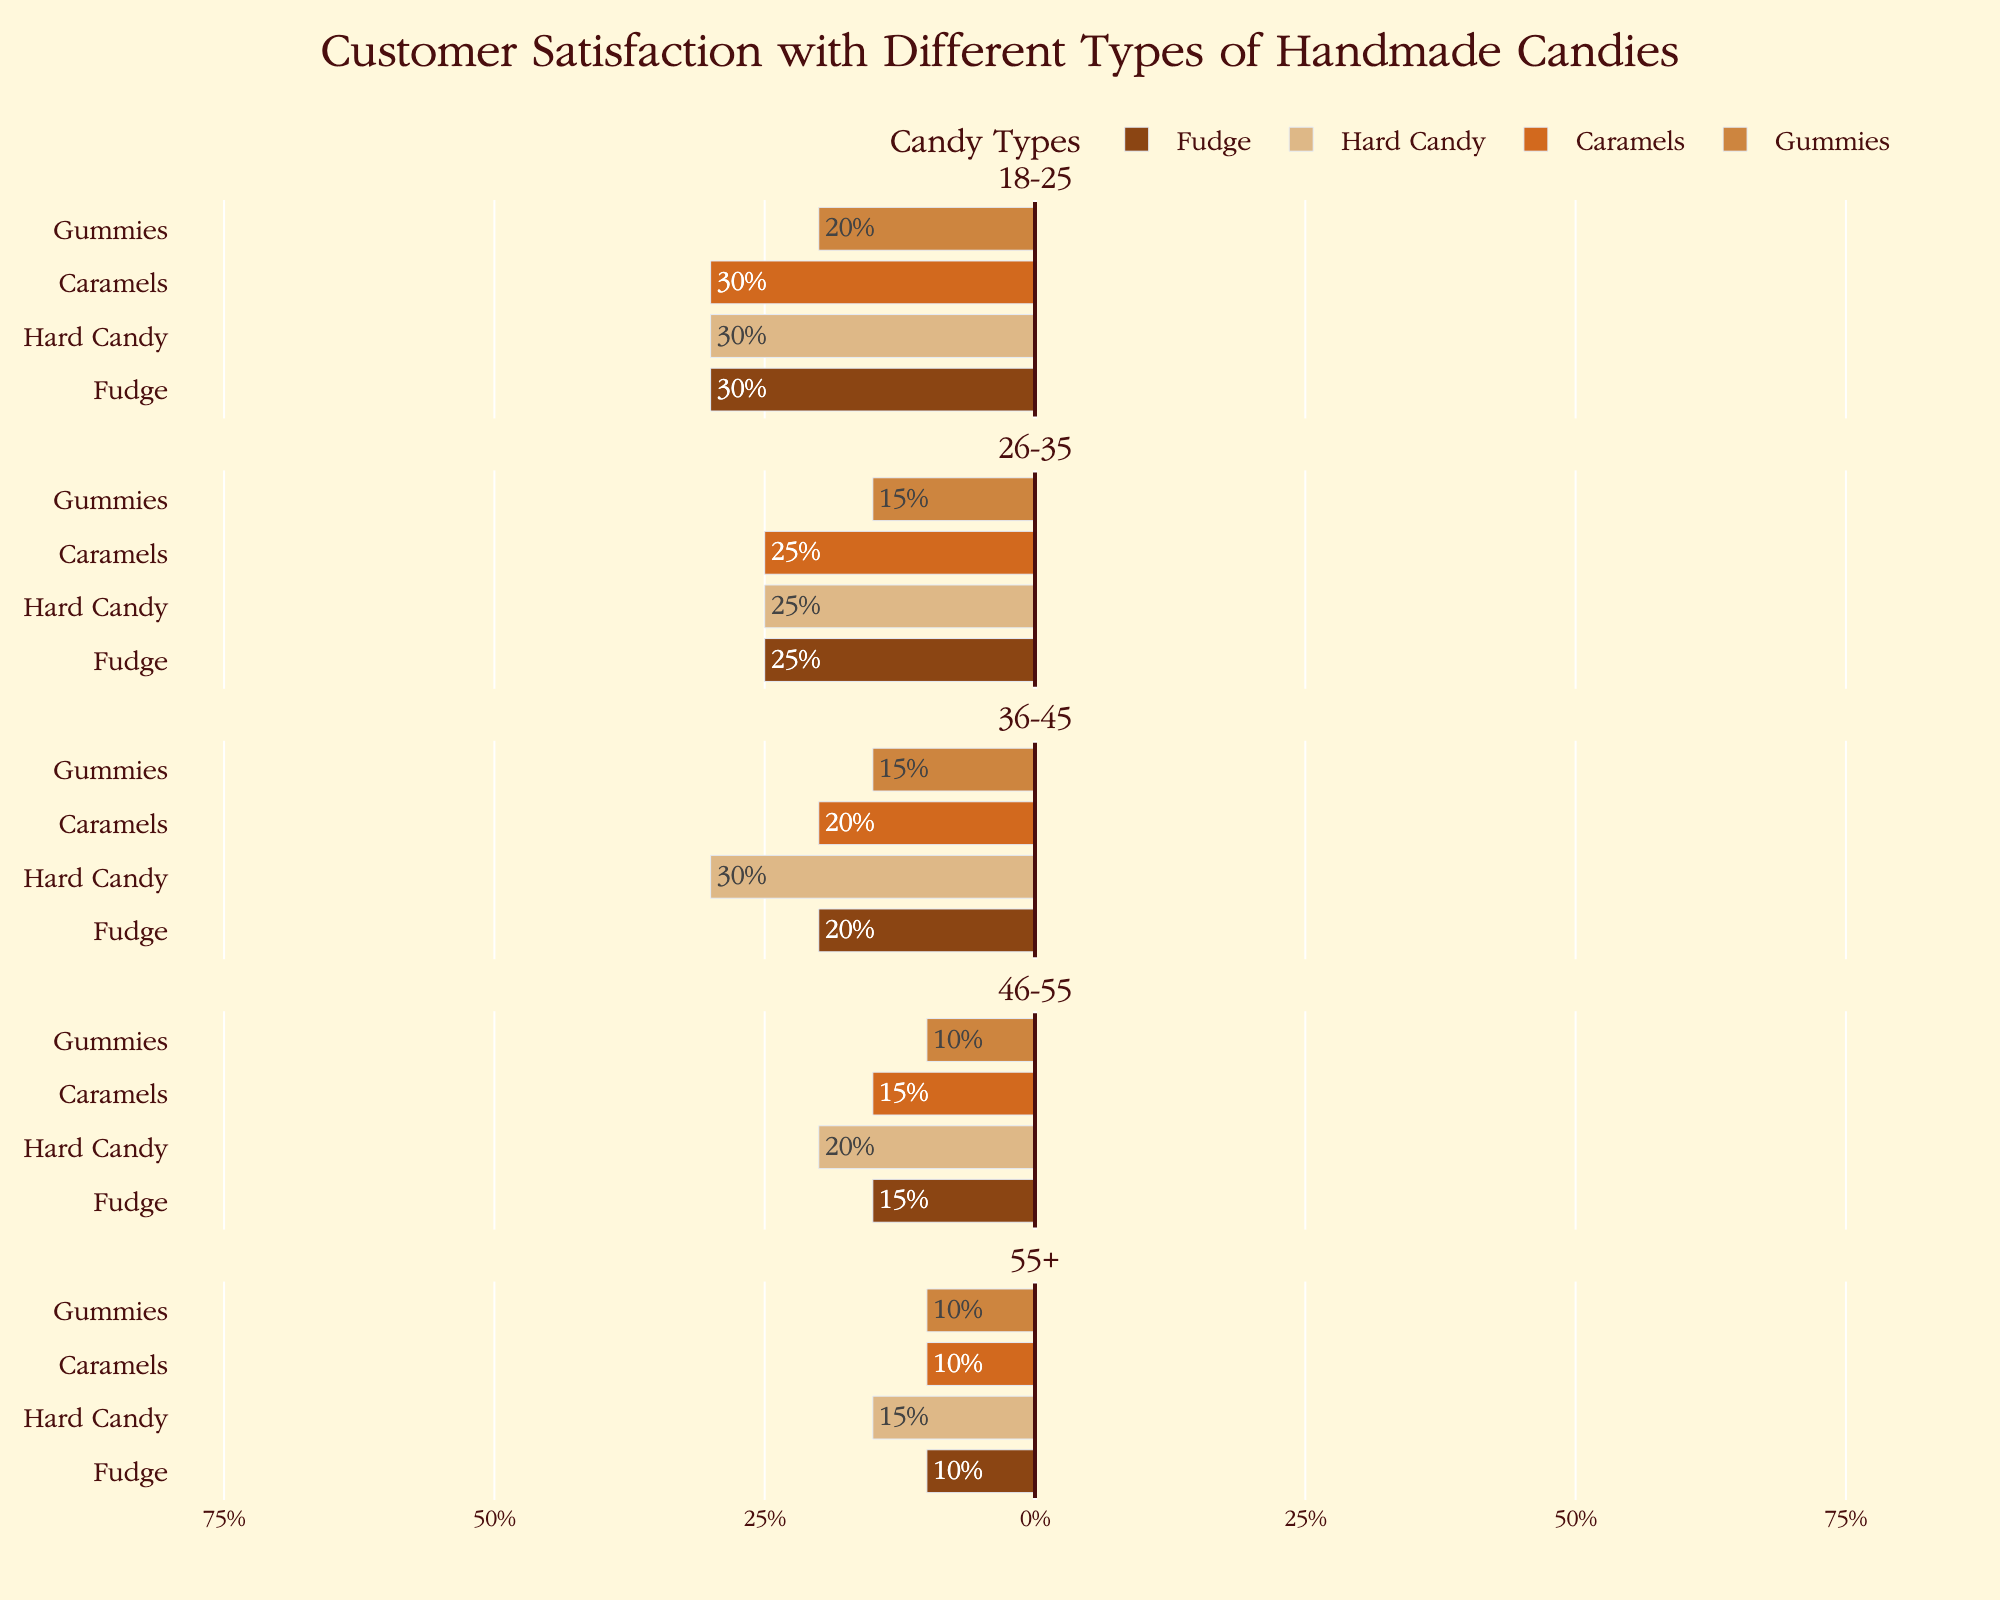Which age group has the highest satisfaction rate for Fudge? The figure shows satisfaction rates divided by age group and candy type. Look at the section for Fudge across all age groups and identify the one with the highest percentage in the "Satisfied" section.
Answer: 55+ What is the difference in satisfaction rates for Gummies between the 18-25 and 36-45 age groups? Compare the satisfaction rates for Gummies in both the 18-25 and 36-45 age groups from the figure and subtract the smaller percentage from the larger one.
Answer: 15% Which candy type has the most balanced levels of satisfaction, neutral, and dissatisfaction in the 18-25 age group? In the 18-25 age group section, compare the bars for each candy type. The most balanced will have similar lengths for "Satisfied," "Neutral," and "Dissatisfied" sections.
Answer: Caramels How does the satisfaction rate of Hard Candy for the 55+ age group compare to the same rate for the 26-35 age group? Find the satisfaction rate of Hard Candy for the 55+ age group and compare it to the satisfaction rate for the 26-35 age group. Determine which is higher.
Answer: 55+ is higher by 10% What is the total percentage of Neutral and Dissatisfied responses for Caramels in the 55+ age group? Add the percentages of Neutral and Dissatisfied responses for Caramels in the 55+ age group.
Answer: 30% Which candy has the lowest dissatisfaction rate for the 46-55 age group? Examine the "Dissatisfied" part of the bars in the 46-55 age group and find the smallest percentage.
Answer: Gummies In the 26-35 age group, which candy type has the greatest proportion of satisfied customers? Look at the "Satisfied" portion of each candy type in the 26-35 age group and identify the one with the largest percentage.
Answer: Gummies What is the average satisfaction rate for Fudge across all age groups? Sum the satisfaction rates for Fudge across all age groups and divide by the number of age groups (5). The rates are 40, 50, 60, 70, and 75. The sum is 295, and the average is 295/5.
Answer: 59% Are there any age groups where the satisfaction rate for Caramels is higher than for Gummies? Compare the satisfaction rates for Caramels and Gummies within each age group and check if Caramels is higher in any age group.
Answer: No Which age group has the smallest range between their highest and lowest satisfaction rates for any candy type? For each age group, find the range (highest satisfaction rate - lowest satisfaction rate) and determine the smallest range.
Answer: 46-55 